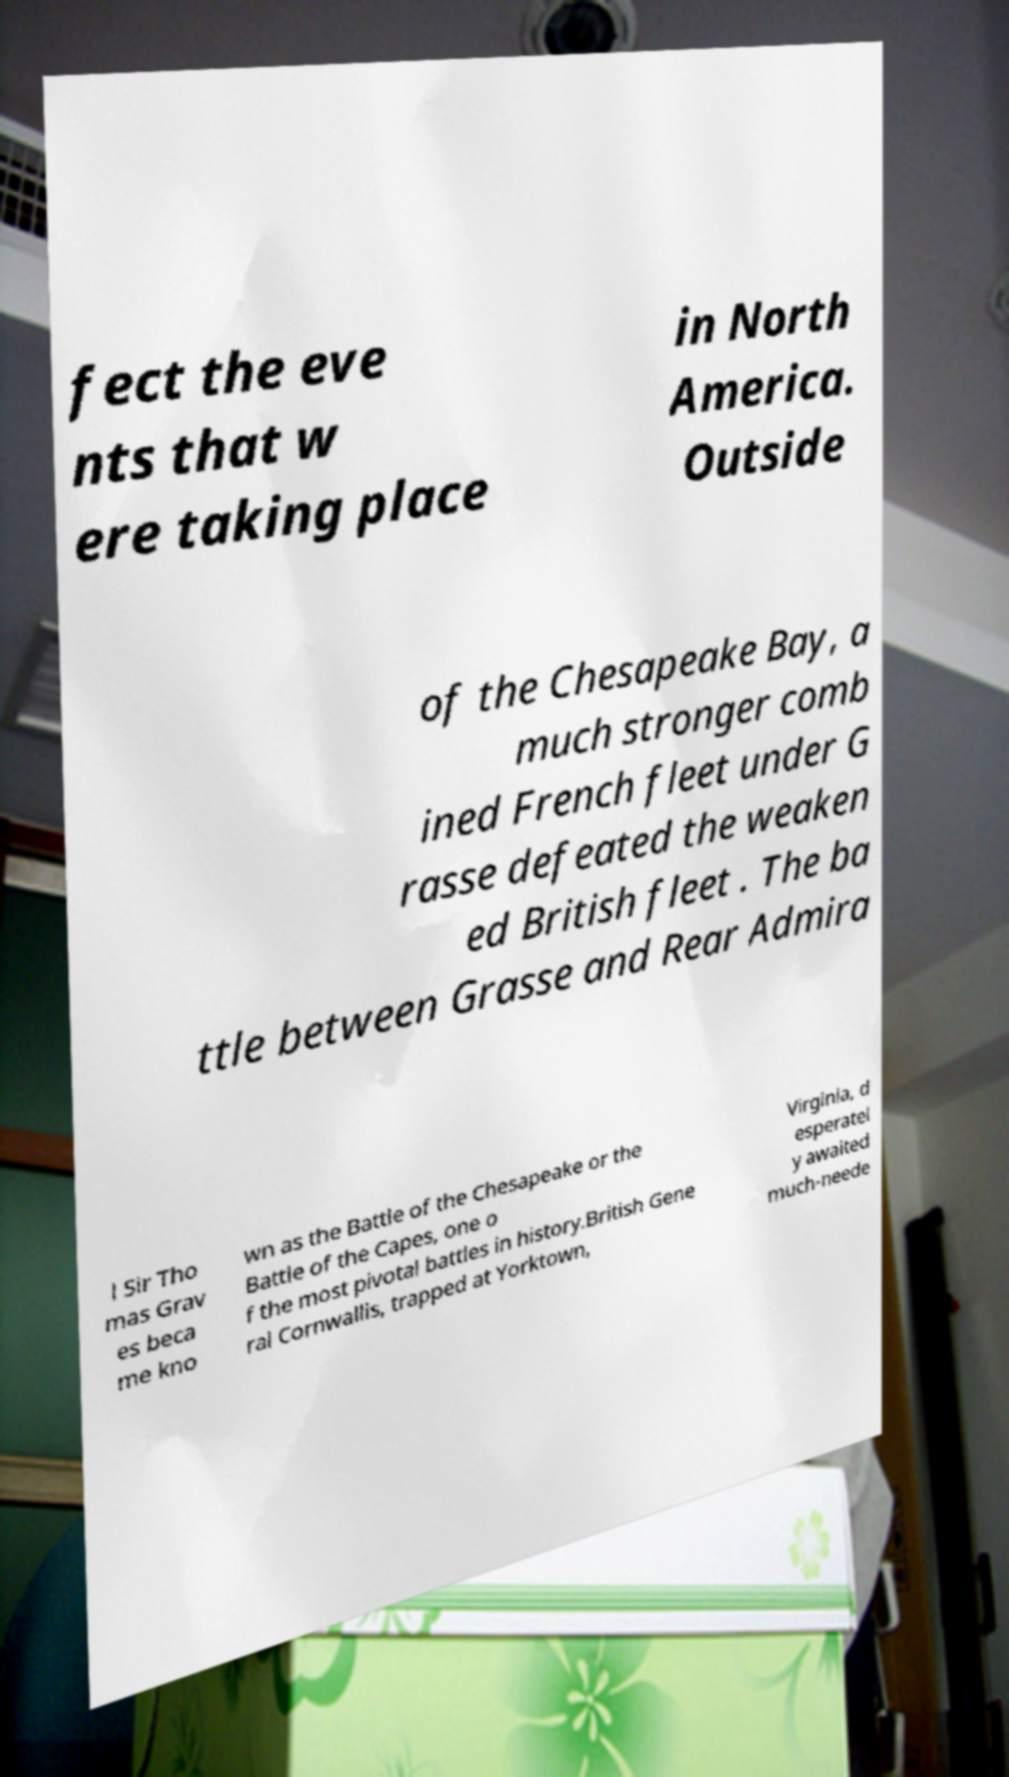I need the written content from this picture converted into text. Can you do that? fect the eve nts that w ere taking place in North America. Outside of the Chesapeake Bay, a much stronger comb ined French fleet under G rasse defeated the weaken ed British fleet . The ba ttle between Grasse and Rear Admira l Sir Tho mas Grav es beca me kno wn as the Battle of the Chesapeake or the Battle of the Capes, one o f the most pivotal battles in history.British Gene ral Cornwallis, trapped at Yorktown, Virginia, d esperatel y awaited much-neede 